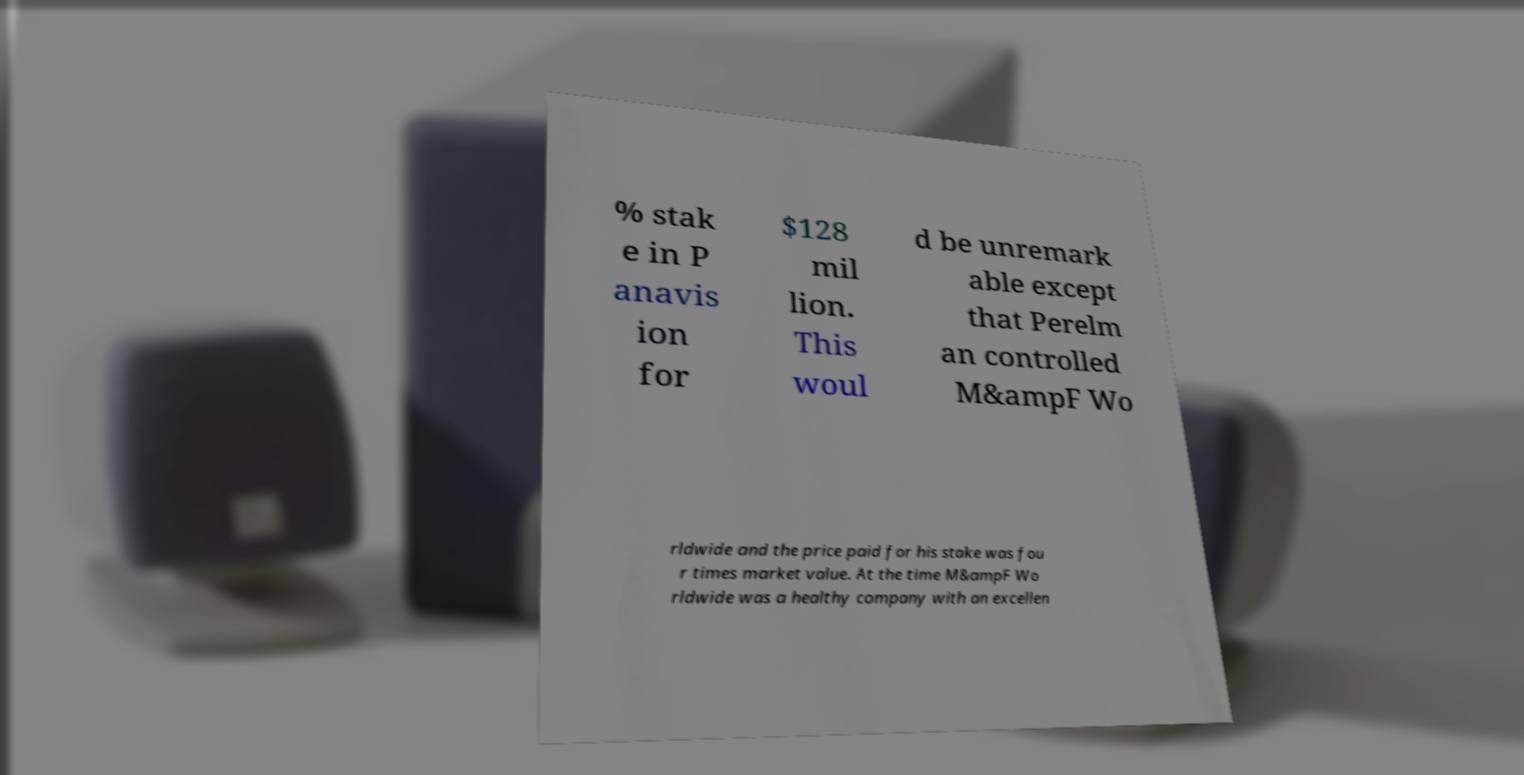Could you extract and type out the text from this image? % stak e in P anavis ion for $128 mil lion. This woul d be unremark able except that Perelm an controlled M&ampF Wo rldwide and the price paid for his stake was fou r times market value. At the time M&ampF Wo rldwide was a healthy company with an excellen 